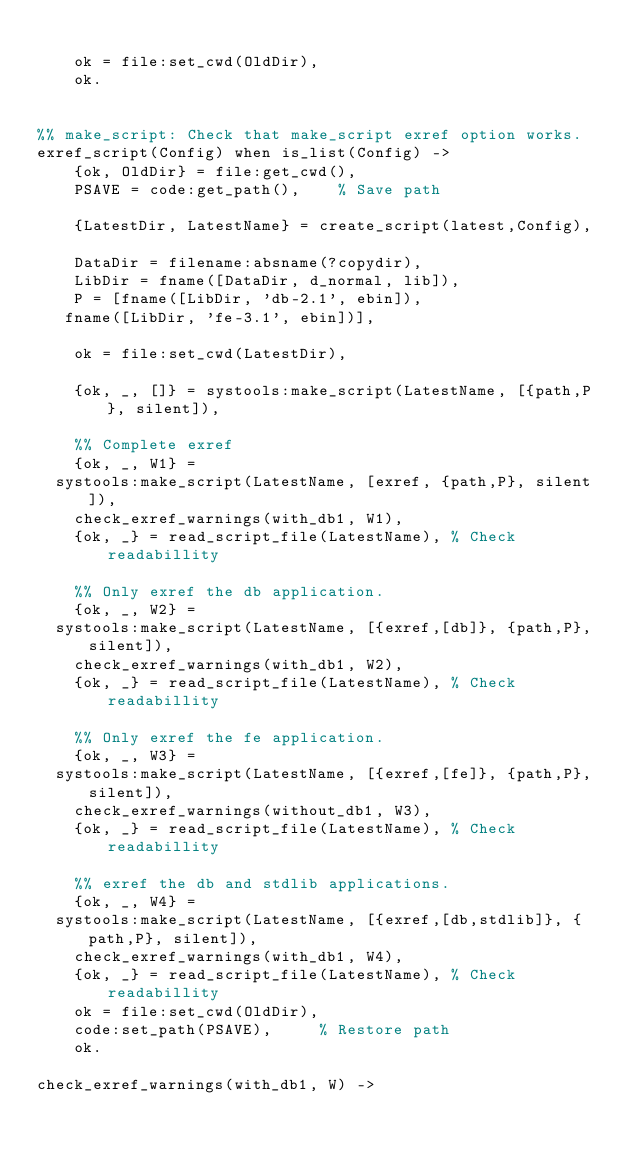<code> <loc_0><loc_0><loc_500><loc_500><_Erlang_>
    ok = file:set_cwd(OldDir),
    ok.


%% make_script: Check that make_script exref option works.
exref_script(Config) when is_list(Config) ->
    {ok, OldDir} = file:get_cwd(),
    PSAVE = code:get_path(),		% Save path

    {LatestDir, LatestName} = create_script(latest,Config),

    DataDir = filename:absname(?copydir),
    LibDir = fname([DataDir, d_normal, lib]),
    P = [fname([LibDir, 'db-2.1', ebin]),
	 fname([LibDir, 'fe-3.1', ebin])],

    ok = file:set_cwd(LatestDir),

    {ok, _, []} = systools:make_script(LatestName, [{path,P}, silent]),

    %% Complete exref
    {ok, _, W1} =
	systools:make_script(LatestName, [exref, {path,P}, silent]),
    check_exref_warnings(with_db1, W1),
    {ok, _} = read_script_file(LatestName),	% Check readabillity

    %% Only exref the db application.
    {ok, _, W2} =
	systools:make_script(LatestName, [{exref,[db]}, {path,P}, silent]),
    check_exref_warnings(with_db1, W2),
    {ok, _} = read_script_file(LatestName),	% Check readabillity

    %% Only exref the fe application.
    {ok, _, W3} =
	systools:make_script(LatestName, [{exref,[fe]}, {path,P}, silent]),
    check_exref_warnings(without_db1, W3),
    {ok, _} = read_script_file(LatestName),	% Check readabillity

    %% exref the db and stdlib applications.
    {ok, _, W4} =
	systools:make_script(LatestName, [{exref,[db,stdlib]}, {path,P}, silent]),
    check_exref_warnings(with_db1, W4),
    {ok, _} = read_script_file(LatestName),	% Check readabillity
    ok = file:set_cwd(OldDir),
    code:set_path(PSAVE),			% Restore path
    ok.

check_exref_warnings(with_db1, W) -></code> 